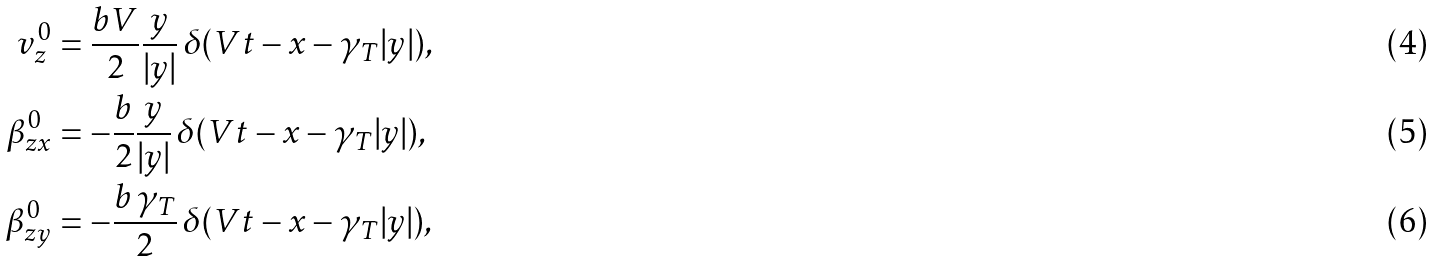Convert formula to latex. <formula><loc_0><loc_0><loc_500><loc_500>v _ { z } ^ { 0 } & = \frac { b V } { 2 } \frac { y } { | y | } \, \delta ( V t - x - \gamma _ { T } | y | ) , \\ \beta _ { z x } ^ { 0 } & = - \frac { b } { 2 } \frac { y } { | y | } \, \delta ( V t - x - \gamma _ { T } | y | ) , \\ \beta _ { z y } ^ { 0 } & = - \frac { b \, \gamma _ { T } } { 2 } \, \delta ( V t - x - \gamma _ { T } | y | ) ,</formula> 